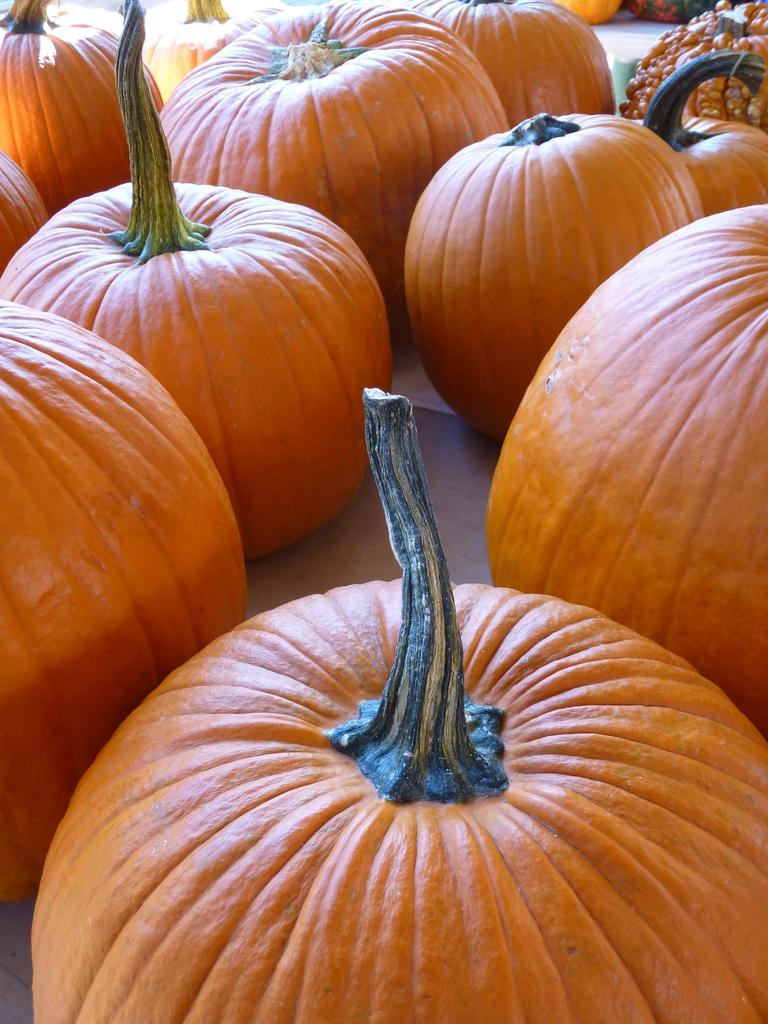What type of vegetable is present in the image? There are pumpkins in the image. What part of the image can be seen in the center? The floor is visible in the center of the image. Who is the creator of the pumpkins in the image? The text does not mention a creator for the pumpkins, and it is not possible to determine who created them from the image alone. 